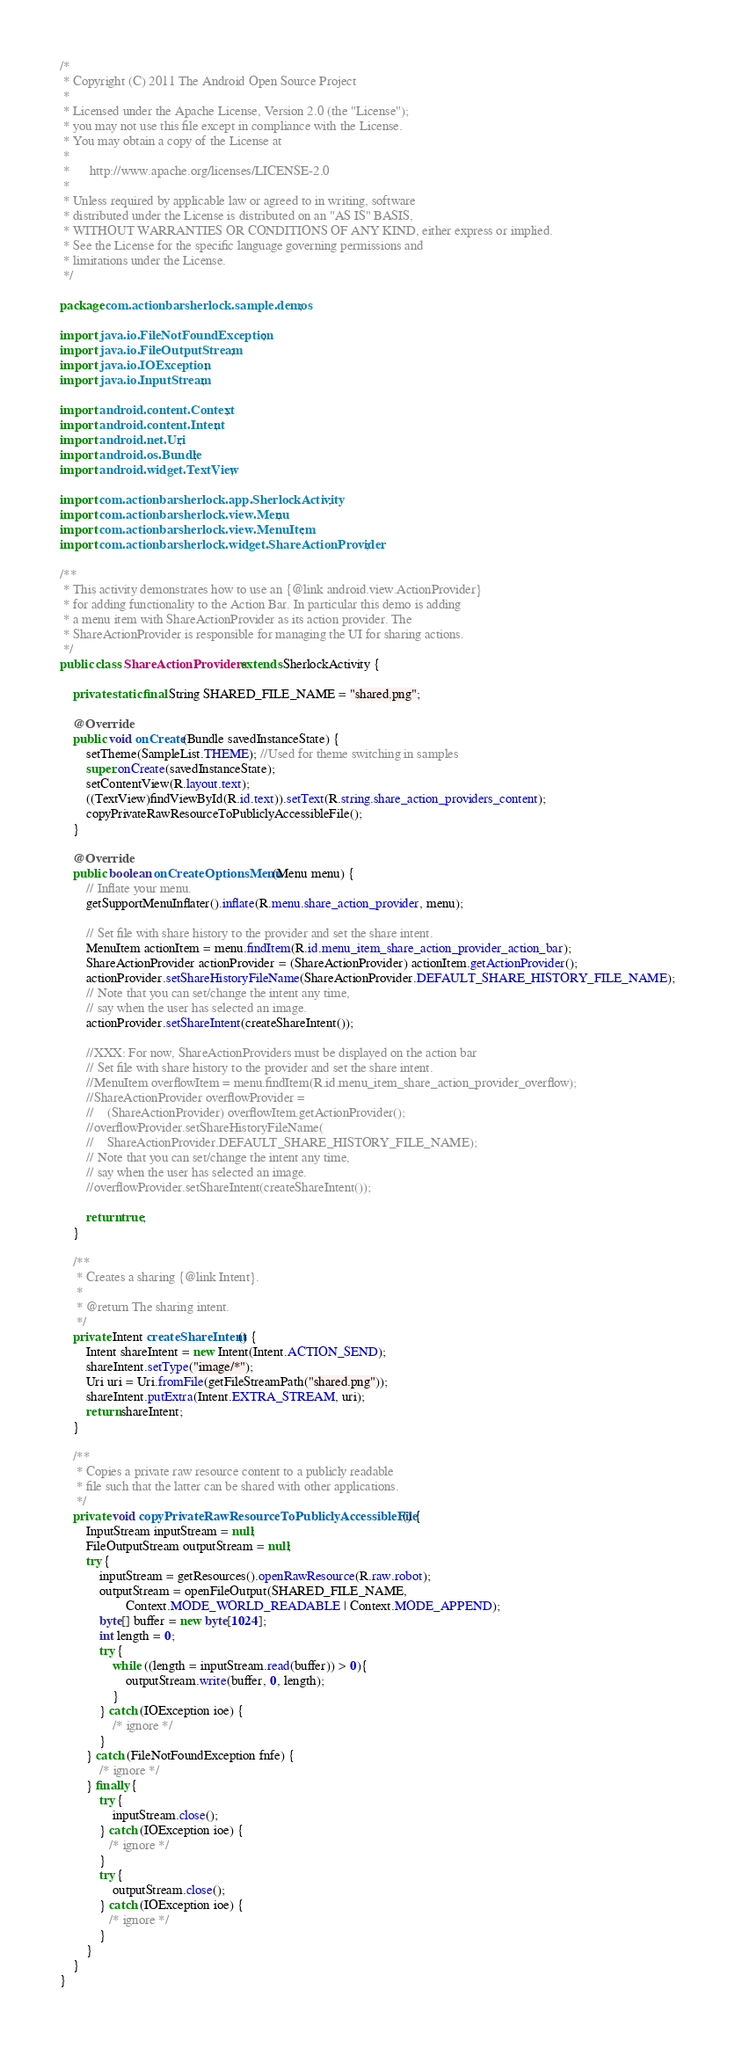<code> <loc_0><loc_0><loc_500><loc_500><_Java_>/*
 * Copyright (C) 2011 The Android Open Source Project
 *
 * Licensed under the Apache License, Version 2.0 (the "License");
 * you may not use this file except in compliance with the License.
 * You may obtain a copy of the License at
 *
 *      http://www.apache.org/licenses/LICENSE-2.0
 *
 * Unless required by applicable law or agreed to in writing, software
 * distributed under the License is distributed on an "AS IS" BASIS,
 * WITHOUT WARRANTIES OR CONDITIONS OF ANY KIND, either express or implied.
 * See the License for the specific language governing permissions and
 * limitations under the License.
 */

package com.actionbarsherlock.sample.demos;

import java.io.FileNotFoundException;
import java.io.FileOutputStream;
import java.io.IOException;
import java.io.InputStream;

import android.content.Context;
import android.content.Intent;
import android.net.Uri;
import android.os.Bundle;
import android.widget.TextView;

import com.actionbarsherlock.app.SherlockActivity;
import com.actionbarsherlock.view.Menu;
import com.actionbarsherlock.view.MenuItem;
import com.actionbarsherlock.widget.ShareActionProvider;

/**
 * This activity demonstrates how to use an {@link android.view.ActionProvider}
 * for adding functionality to the Action Bar. In particular this demo is adding
 * a menu item with ShareActionProvider as its action provider. The
 * ShareActionProvider is responsible for managing the UI for sharing actions.
 */
public class ShareActionProviders extends SherlockActivity {

    private static final String SHARED_FILE_NAME = "shared.png";

    @Override
    public void onCreate(Bundle savedInstanceState) {
        setTheme(SampleList.THEME); //Used for theme switching in samples
        super.onCreate(savedInstanceState);
        setContentView(R.layout.text);
        ((TextView)findViewById(R.id.text)).setText(R.string.share_action_providers_content);
        copyPrivateRawResourceToPubliclyAccessibleFile();
    }

    @Override
    public boolean onCreateOptionsMenu(Menu menu) {
        // Inflate your menu.
        getSupportMenuInflater().inflate(R.menu.share_action_provider, menu);

        // Set file with share history to the provider and set the share intent.
        MenuItem actionItem = menu.findItem(R.id.menu_item_share_action_provider_action_bar);
        ShareActionProvider actionProvider = (ShareActionProvider) actionItem.getActionProvider();
        actionProvider.setShareHistoryFileName(ShareActionProvider.DEFAULT_SHARE_HISTORY_FILE_NAME);
        // Note that you can set/change the intent any time,
        // say when the user has selected an image.
        actionProvider.setShareIntent(createShareIntent());

        //XXX: For now, ShareActionProviders must be displayed on the action bar
        // Set file with share history to the provider and set the share intent.
        //MenuItem overflowItem = menu.findItem(R.id.menu_item_share_action_provider_overflow);
        //ShareActionProvider overflowProvider =
        //    (ShareActionProvider) overflowItem.getActionProvider();
        //overflowProvider.setShareHistoryFileName(
        //    ShareActionProvider.DEFAULT_SHARE_HISTORY_FILE_NAME);
        // Note that you can set/change the intent any time,
        // say when the user has selected an image.
        //overflowProvider.setShareIntent(createShareIntent());

        return true;
    }

    /**
     * Creates a sharing {@link Intent}.
     *
     * @return The sharing intent.
     */
    private Intent createShareIntent() {
        Intent shareIntent = new Intent(Intent.ACTION_SEND);
        shareIntent.setType("image/*");
        Uri uri = Uri.fromFile(getFileStreamPath("shared.png"));
        shareIntent.putExtra(Intent.EXTRA_STREAM, uri);
        return shareIntent;
    }

    /**
     * Copies a private raw resource content to a publicly readable
     * file such that the latter can be shared with other applications.
     */
    private void copyPrivateRawResourceToPubliclyAccessibleFile() {
        InputStream inputStream = null;
        FileOutputStream outputStream = null;
        try {
            inputStream = getResources().openRawResource(R.raw.robot);
            outputStream = openFileOutput(SHARED_FILE_NAME,
                    Context.MODE_WORLD_READABLE | Context.MODE_APPEND);
            byte[] buffer = new byte[1024];
            int length = 0;
            try {
                while ((length = inputStream.read(buffer)) > 0){
                    outputStream.write(buffer, 0, length);
                }
            } catch (IOException ioe) {
                /* ignore */
            }
        } catch (FileNotFoundException fnfe) {
            /* ignore */
        } finally {
            try {
                inputStream.close();
            } catch (IOException ioe) {
               /* ignore */
            }
            try {
                outputStream.close();
            } catch (IOException ioe) {
               /* ignore */
            }
        }
    }
}</code> 